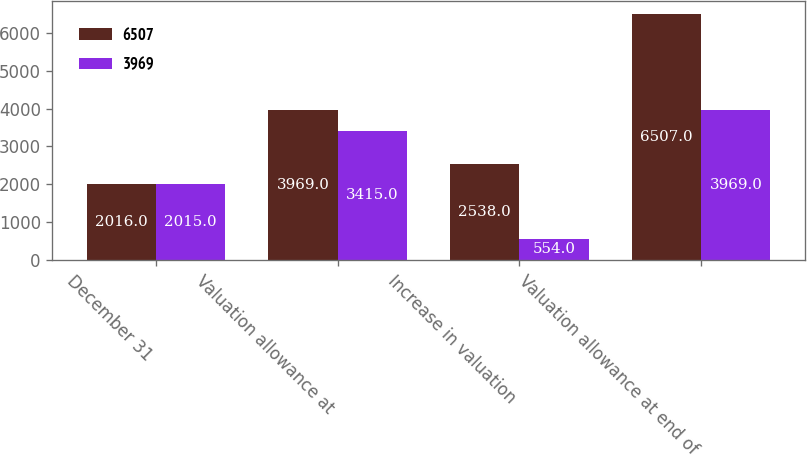Convert chart to OTSL. <chart><loc_0><loc_0><loc_500><loc_500><stacked_bar_chart><ecel><fcel>December 31<fcel>Valuation allowance at<fcel>Increase in valuation<fcel>Valuation allowance at end of<nl><fcel>6507<fcel>2016<fcel>3969<fcel>2538<fcel>6507<nl><fcel>3969<fcel>2015<fcel>3415<fcel>554<fcel>3969<nl></chart> 